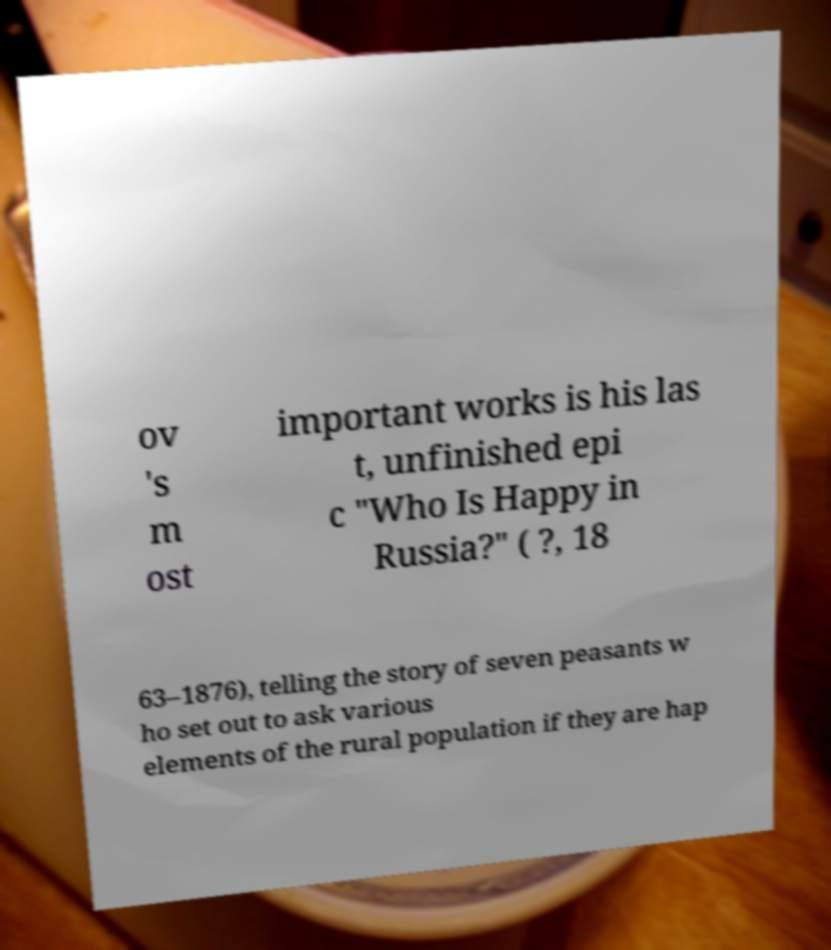What messages or text are displayed in this image? I need them in a readable, typed format. ov 's m ost important works is his las t, unfinished epi c "Who Is Happy in Russia?" ( ?, 18 63–1876), telling the story of seven peasants w ho set out to ask various elements of the rural population if they are hap 